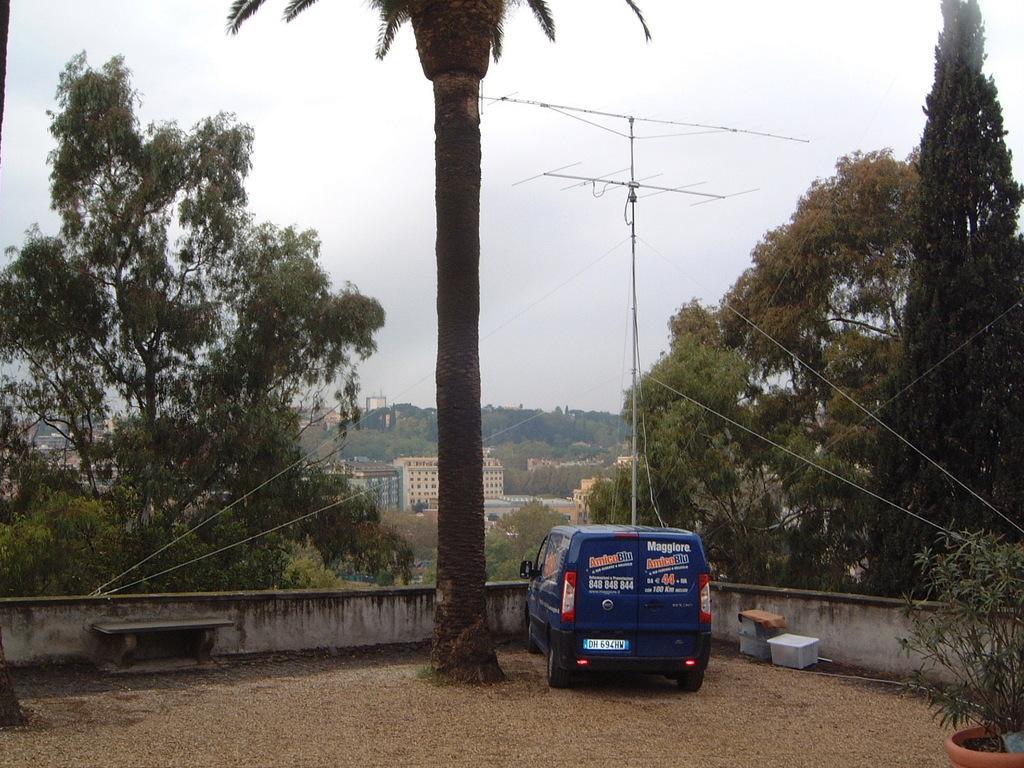In one or two sentences, can you explain what this image depicts? In this picture, we can see the ground with some objects like bench, boxes, plant in a pot, we can see vehicle, wall, trees, buildings with windows, poles, antenna, and the sky. 